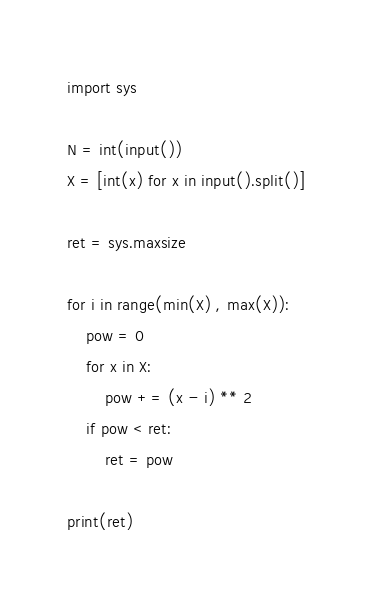Convert code to text. <code><loc_0><loc_0><loc_500><loc_500><_Python_>import sys

N = int(input())
X = [int(x) for x in input().split()]

ret = sys.maxsize

for i in range(min(X) , max(X)):
    pow = 0
    for x in X:
        pow += (x - i) ** 2
    if pow < ret:
        ret = pow

print(ret)</code> 